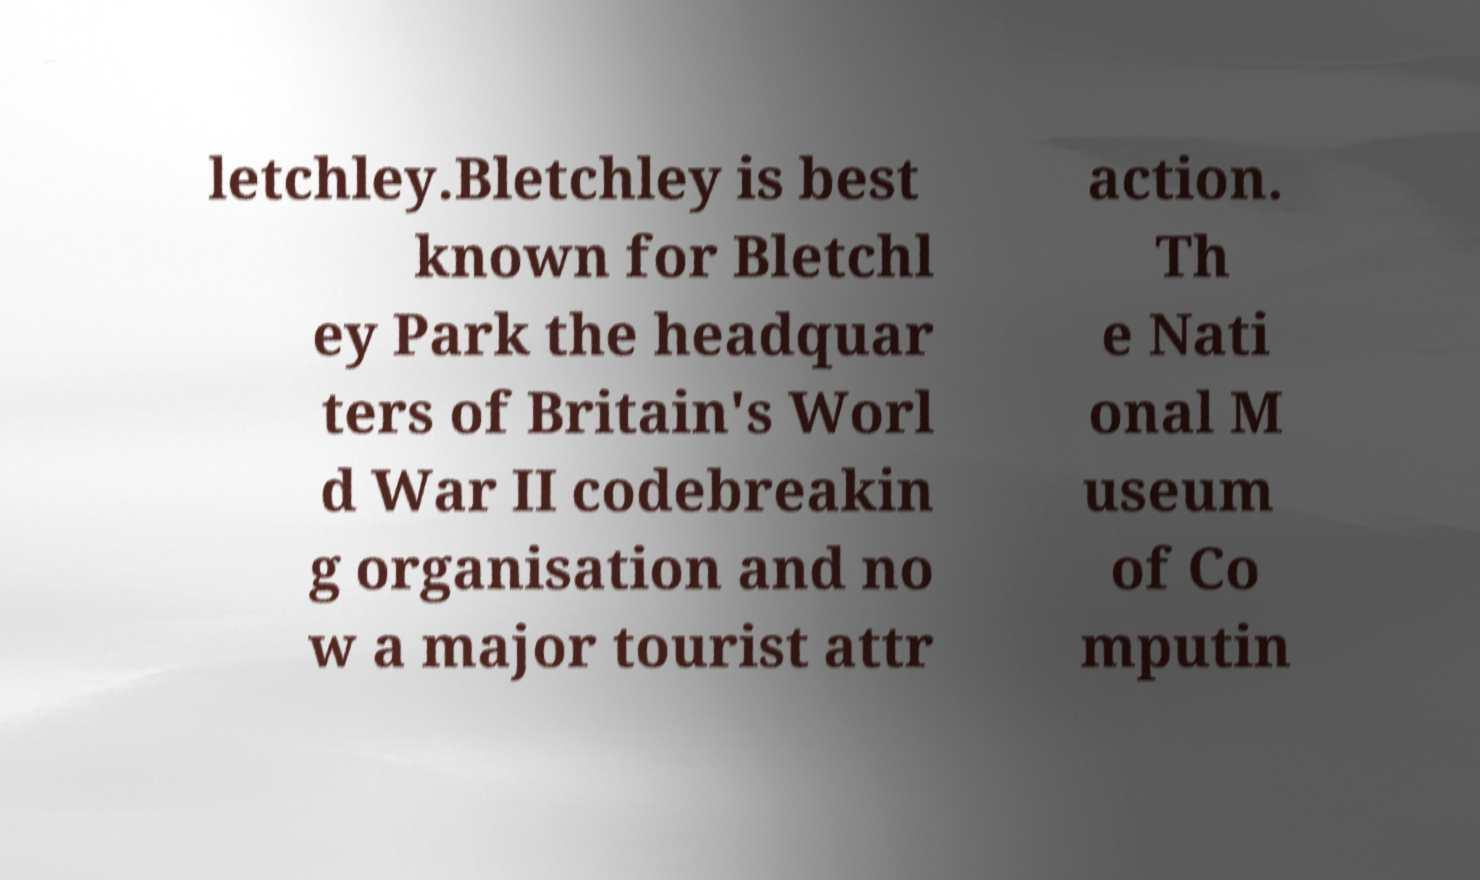Can you accurately transcribe the text from the provided image for me? letchley.Bletchley is best known for Bletchl ey Park the headquar ters of Britain's Worl d War II codebreakin g organisation and no w a major tourist attr action. Th e Nati onal M useum of Co mputin 